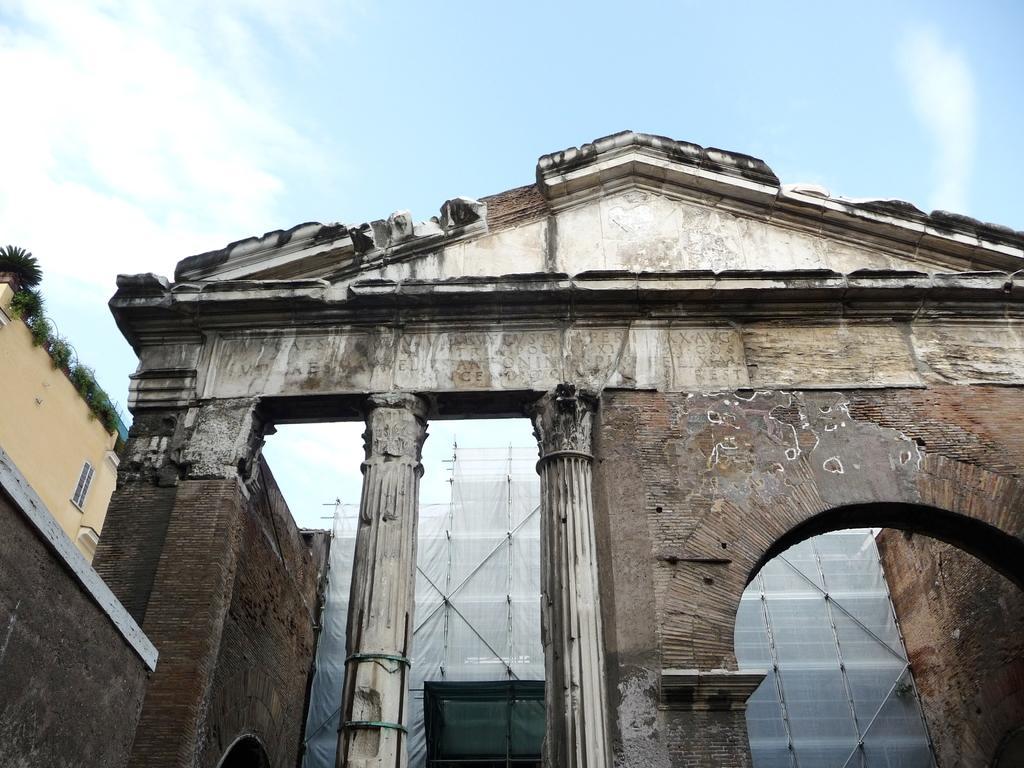How would you summarize this image in a sentence or two? Here we can see buildings,pillars,window and house plants on the left side building. In the background there are poles,cloth and clouds in the sky. 